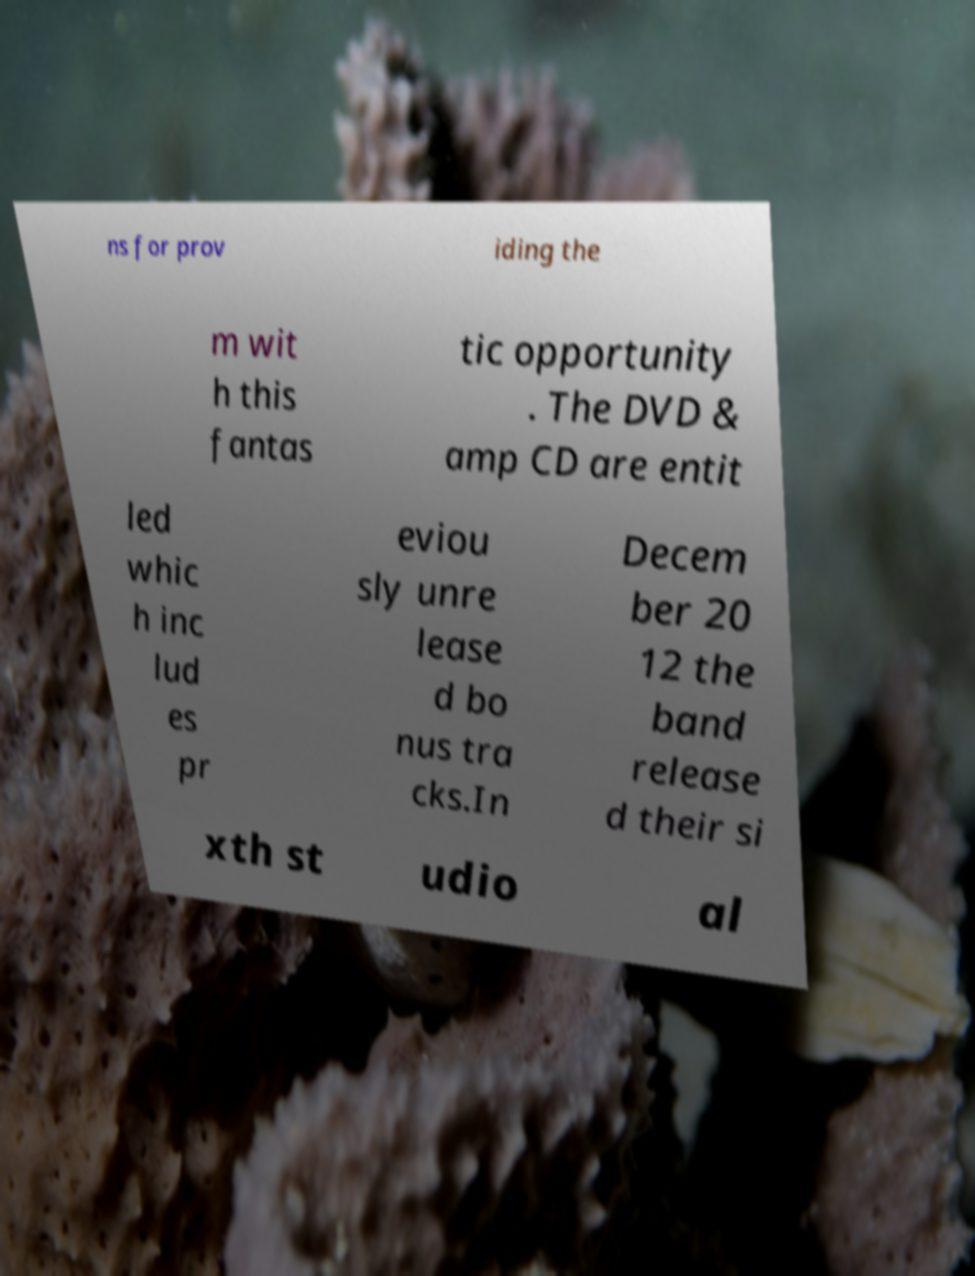Can you accurately transcribe the text from the provided image for me? ns for prov iding the m wit h this fantas tic opportunity . The DVD & amp CD are entit led whic h inc lud es pr eviou sly unre lease d bo nus tra cks.In Decem ber 20 12 the band release d their si xth st udio al 